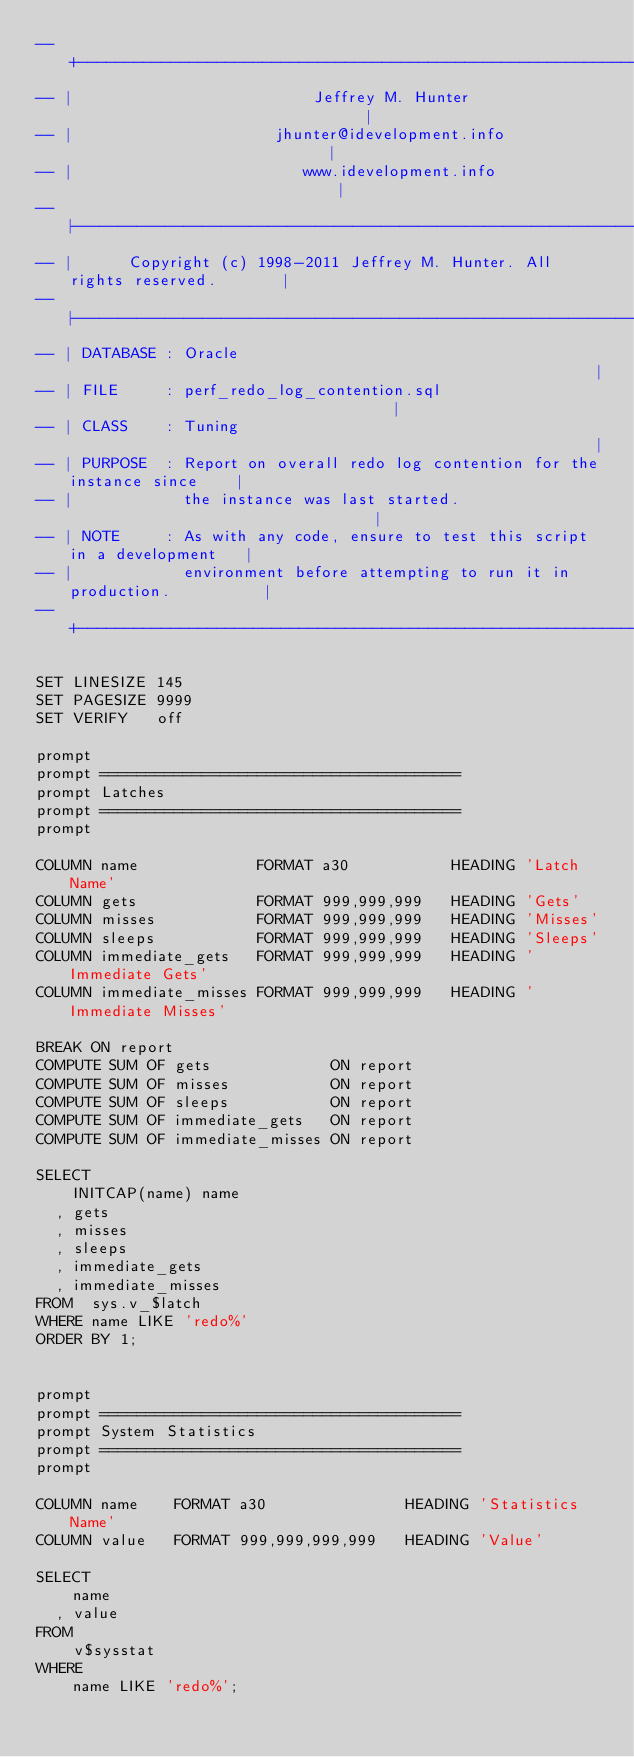<code> <loc_0><loc_0><loc_500><loc_500><_SQL_>-- +----------------------------------------------------------------------------+
-- |                          Jeffrey M. Hunter                                 |
-- |                      jhunter@idevelopment.info                             |
-- |                         www.idevelopment.info                              |
-- |----------------------------------------------------------------------------|
-- |      Copyright (c) 1998-2011 Jeffrey M. Hunter. All rights reserved.       |
-- |----------------------------------------------------------------------------|
-- | DATABASE : Oracle                                                          |
-- | FILE     : perf_redo_log_contention.sql                                    |
-- | CLASS    : Tuning                                                          |
-- | PURPOSE  : Report on overall redo log contention for the instance since    |
-- |            the instance was last started.                                  |
-- | NOTE     : As with any code, ensure to test this script in a development   |
-- |            environment before attempting to run it in production.          |
-- +----------------------------------------------------------------------------+

SET LINESIZE 145
SET PAGESIZE 9999
SET VERIFY   off

prompt
prompt =======================================
prompt Latches
prompt =======================================
prompt 

COLUMN name             FORMAT a30           HEADING 'Latch Name'
COLUMN gets             FORMAT 999,999,999   HEADING 'Gets'
COLUMN misses           FORMAT 999,999,999   HEADING 'Misses'
COLUMN sleeps           FORMAT 999,999,999   HEADING 'Sleeps'
COLUMN immediate_gets   FORMAT 999,999,999   HEADING 'Immediate Gets'
COLUMN immediate_misses FORMAT 999,999,999   HEADING 'Immediate Misses'

BREAK ON report
COMPUTE SUM OF gets             ON report
COMPUTE SUM OF misses           ON report
COMPUTE SUM OF sleeps           ON report
COMPUTE SUM OF immediate_gets   ON report
COMPUTE SUM OF immediate_misses ON report

SELECT 
    INITCAP(name) name
  , gets
  , misses
  , sleeps
  , immediate_gets
  , immediate_misses
FROM  sys.v_$latch
WHERE name LIKE 'redo%'
ORDER BY 1;


prompt
prompt =======================================
prompt System Statistics
prompt =======================================
prompt

COLUMN name    FORMAT a30               HEADING 'Statistics Name'
COLUMN value   FORMAT 999,999,999,999   HEADING 'Value'

SELECT
    name
  , value
FROM
    v$sysstat
WHERE
    name LIKE 'redo%';
</code> 